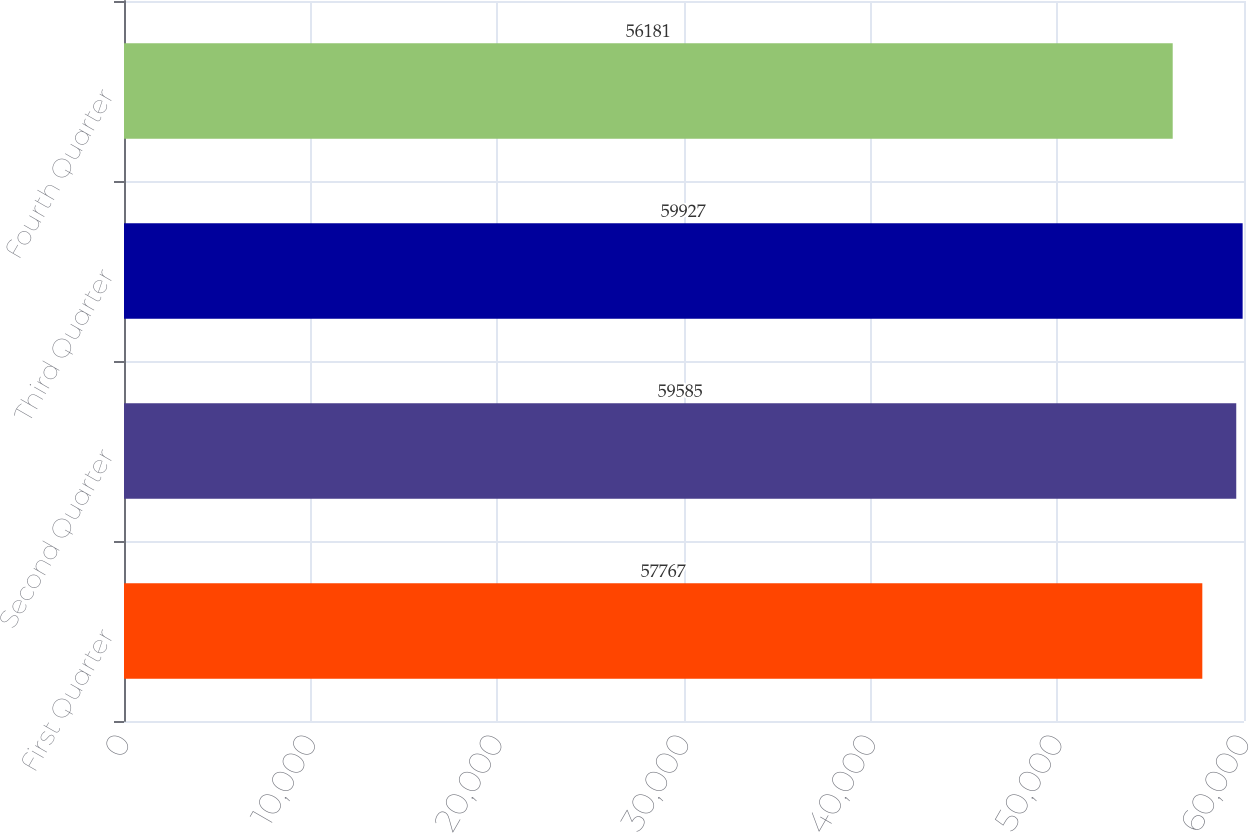<chart> <loc_0><loc_0><loc_500><loc_500><bar_chart><fcel>First Quarter<fcel>Second Quarter<fcel>Third Quarter<fcel>Fourth Quarter<nl><fcel>57767<fcel>59585<fcel>59927<fcel>56181<nl></chart> 